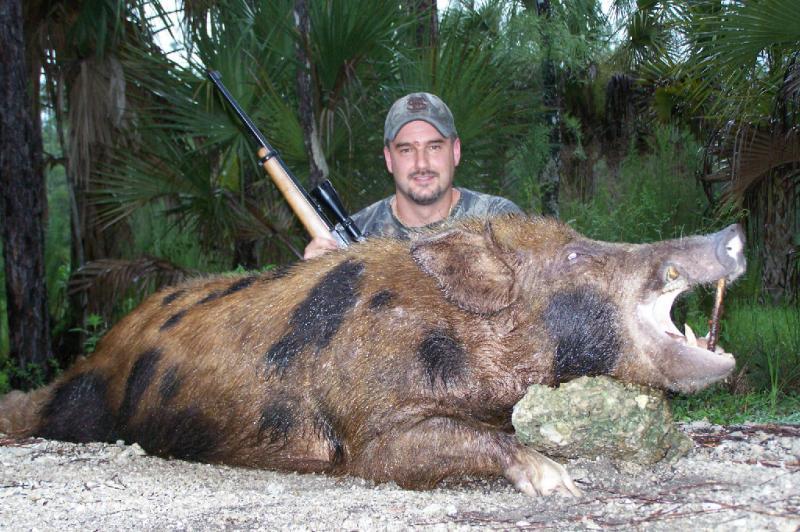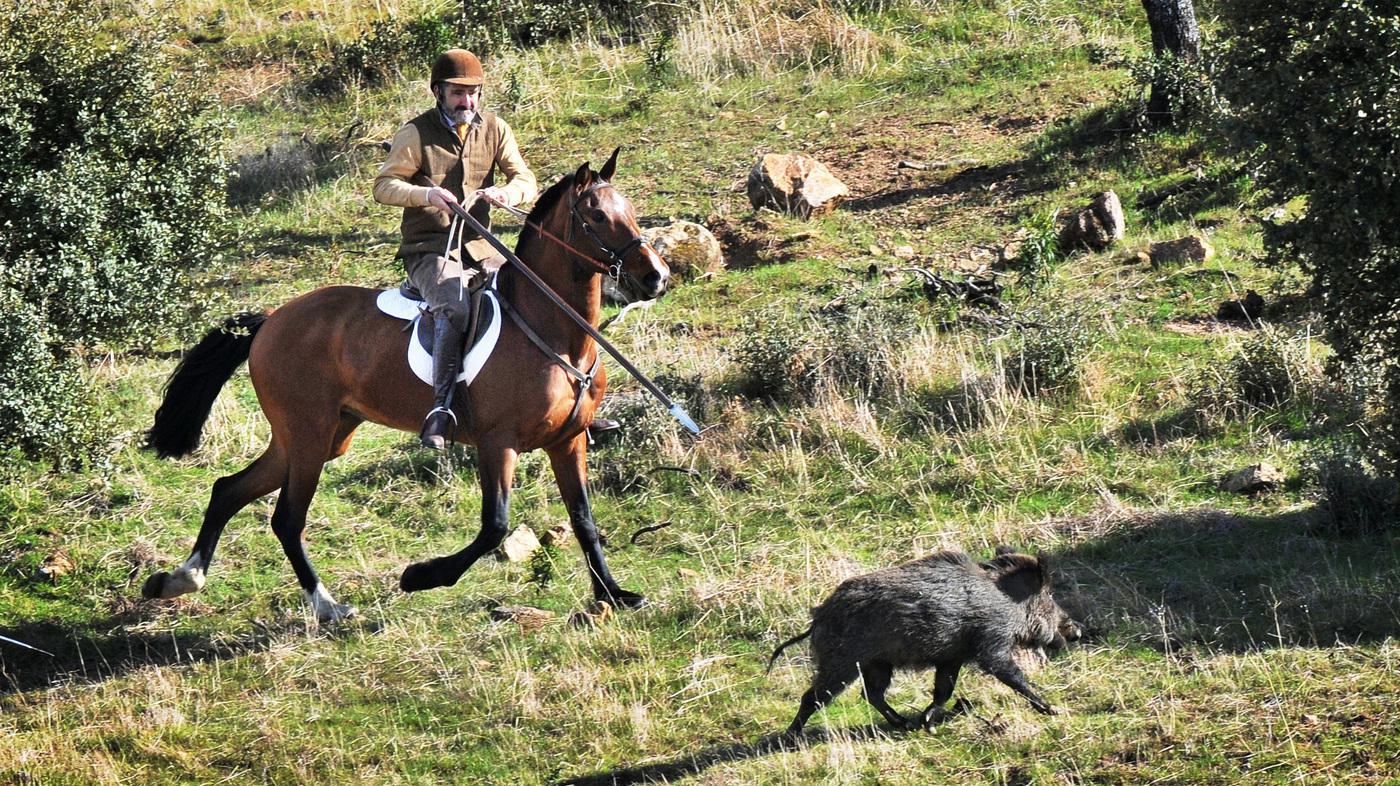The first image is the image on the left, the second image is the image on the right. Considering the images on both sides, is "there is a dead boar with it's mouth wide open and a man with a long blade spear sitting behind it" valid? Answer yes or no. No. The first image is the image on the left, the second image is the image on the right. For the images displayed, is the sentence "A male person grasping a spear in both hands is by a killed hog positioned on the ground with its open-mouthed face toward the camera." factually correct? Answer yes or no. No. 